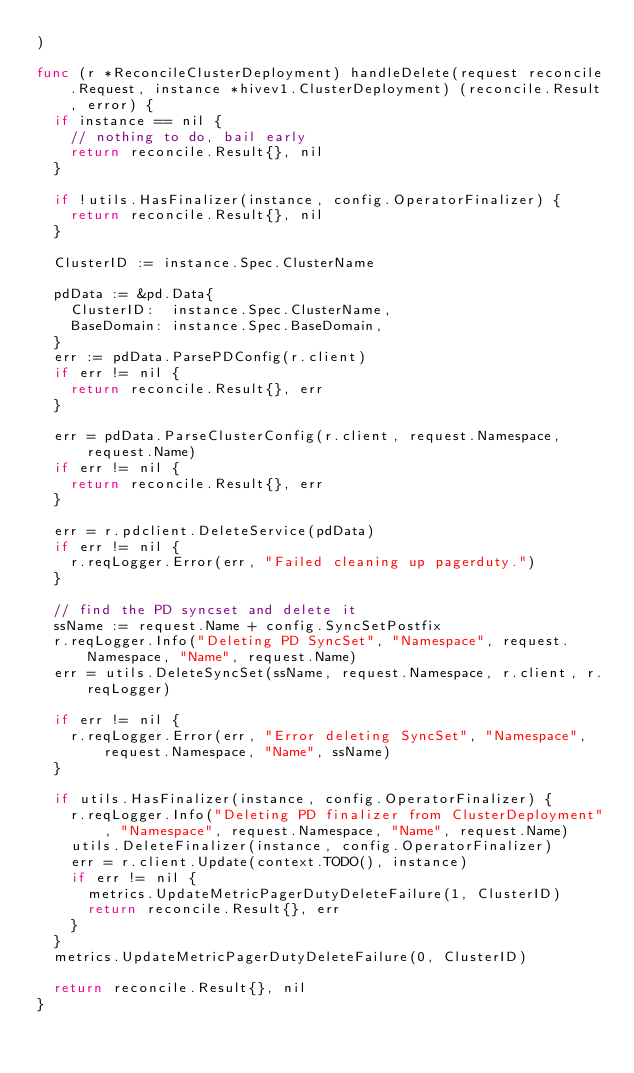<code> <loc_0><loc_0><loc_500><loc_500><_Go_>)

func (r *ReconcileClusterDeployment) handleDelete(request reconcile.Request, instance *hivev1.ClusterDeployment) (reconcile.Result, error) {
	if instance == nil {
		// nothing to do, bail early
		return reconcile.Result{}, nil
	}

	if !utils.HasFinalizer(instance, config.OperatorFinalizer) {
		return reconcile.Result{}, nil
	}

	ClusterID := instance.Spec.ClusterName

	pdData := &pd.Data{
		ClusterID:  instance.Spec.ClusterName,
		BaseDomain: instance.Spec.BaseDomain,
	}
	err := pdData.ParsePDConfig(r.client)
	if err != nil {
		return reconcile.Result{}, err
	}

	err = pdData.ParseClusterConfig(r.client, request.Namespace, request.Name)
	if err != nil {
		return reconcile.Result{}, err
	}

	err = r.pdclient.DeleteService(pdData)
	if err != nil {
		r.reqLogger.Error(err, "Failed cleaning up pagerduty.")
	}

	// find the PD syncset and delete it
	ssName := request.Name + config.SyncSetPostfix
	r.reqLogger.Info("Deleting PD SyncSet", "Namespace", request.Namespace, "Name", request.Name)
	err = utils.DeleteSyncSet(ssName, request.Namespace, r.client, r.reqLogger)

	if err != nil {
		r.reqLogger.Error(err, "Error deleting SyncSet", "Namespace", request.Namespace, "Name", ssName)
	}

	if utils.HasFinalizer(instance, config.OperatorFinalizer) {
		r.reqLogger.Info("Deleting PD finalizer from ClusterDeployment", "Namespace", request.Namespace, "Name", request.Name)
		utils.DeleteFinalizer(instance, config.OperatorFinalizer)
		err = r.client.Update(context.TODO(), instance)
		if err != nil {
			metrics.UpdateMetricPagerDutyDeleteFailure(1, ClusterID)
			return reconcile.Result{}, err
		}
	}
	metrics.UpdateMetricPagerDutyDeleteFailure(0, ClusterID)

	return reconcile.Result{}, nil
}
</code> 